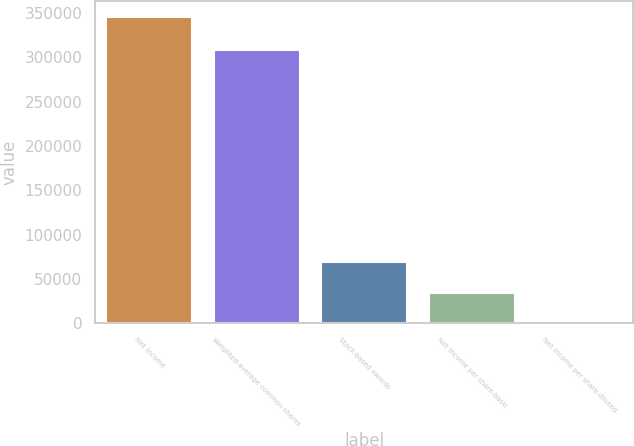<chart> <loc_0><loc_0><loc_500><loc_500><bar_chart><fcel>Net income<fcel>Weighted-average common shares<fcel>Stock-based awards<fcel>Net income per share-basic<fcel>Net income per share-diluted<nl><fcel>345777<fcel>308307<fcel>69156.4<fcel>34578.8<fcel>1.23<nl></chart> 